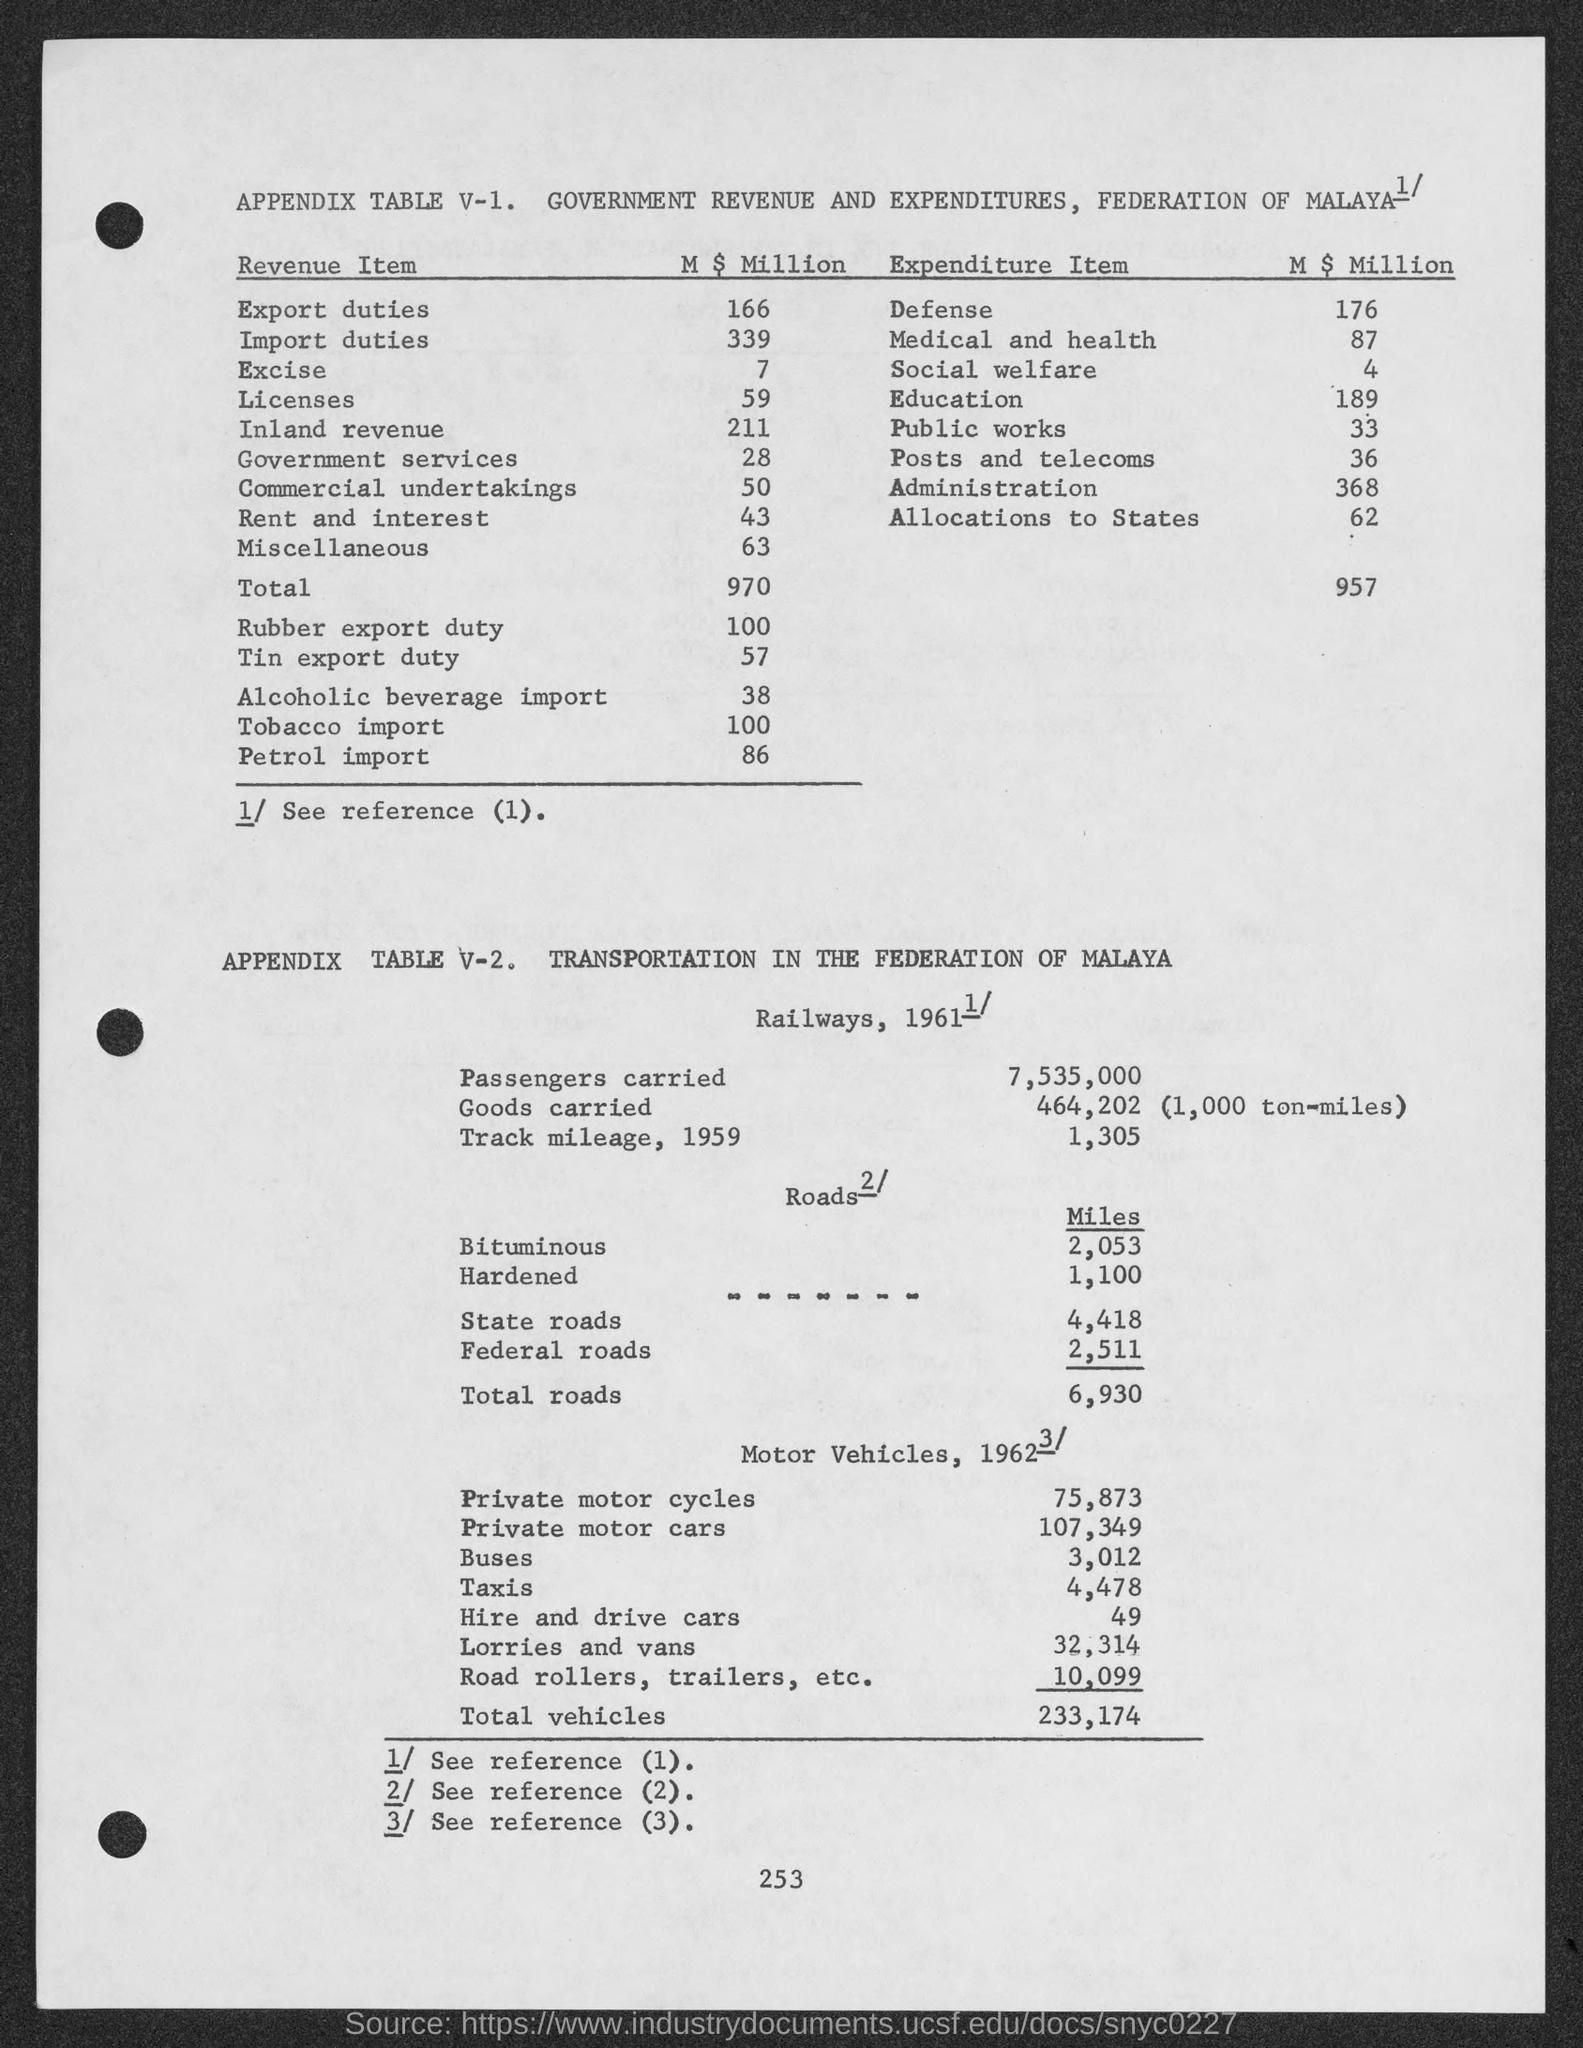What are the Export duties in M $ Million?
Your response must be concise. 166. 